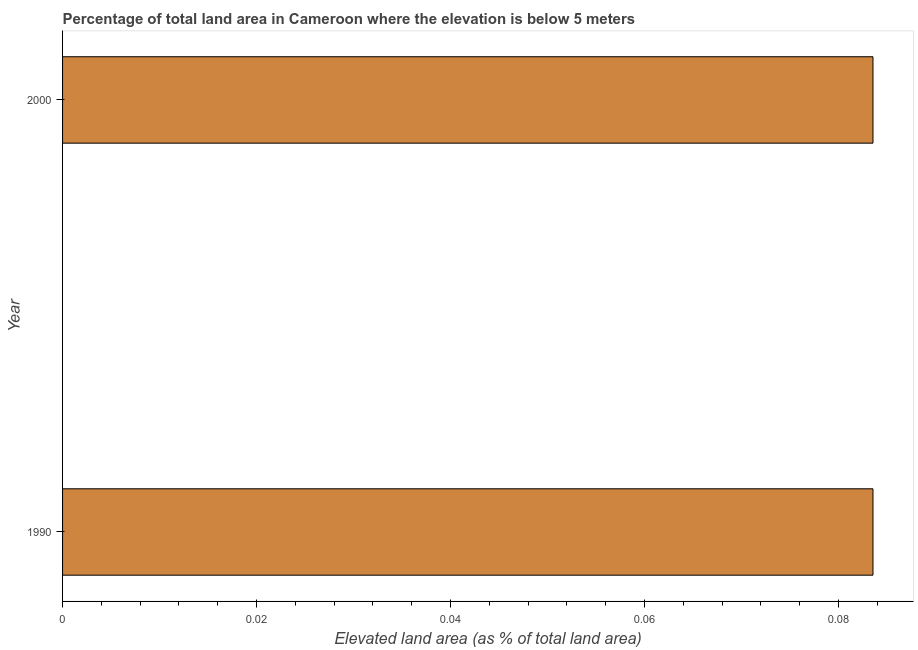Does the graph contain any zero values?
Your answer should be compact. No. Does the graph contain grids?
Your response must be concise. No. What is the title of the graph?
Provide a succinct answer. Percentage of total land area in Cameroon where the elevation is below 5 meters. What is the label or title of the X-axis?
Ensure brevity in your answer.  Elevated land area (as % of total land area). What is the label or title of the Y-axis?
Keep it short and to the point. Year. What is the total elevated land area in 1990?
Keep it short and to the point. 0.08. Across all years, what is the maximum total elevated land area?
Your answer should be compact. 0.08. Across all years, what is the minimum total elevated land area?
Keep it short and to the point. 0.08. In which year was the total elevated land area maximum?
Give a very brief answer. 1990. What is the sum of the total elevated land area?
Ensure brevity in your answer.  0.17. What is the difference between the total elevated land area in 1990 and 2000?
Your answer should be compact. 0. What is the average total elevated land area per year?
Provide a short and direct response. 0.08. What is the median total elevated land area?
Provide a succinct answer. 0.08. In how many years, is the total elevated land area greater than 0.056 %?
Your answer should be compact. 2. Do a majority of the years between 1990 and 2000 (inclusive) have total elevated land area greater than 0.06 %?
Make the answer very short. Yes. Is the total elevated land area in 1990 less than that in 2000?
Offer a very short reply. No. In how many years, is the total elevated land area greater than the average total elevated land area taken over all years?
Offer a terse response. 0. Are all the bars in the graph horizontal?
Offer a very short reply. Yes. How many years are there in the graph?
Offer a terse response. 2. What is the difference between two consecutive major ticks on the X-axis?
Offer a very short reply. 0.02. Are the values on the major ticks of X-axis written in scientific E-notation?
Provide a succinct answer. No. What is the Elevated land area (as % of total land area) of 1990?
Give a very brief answer. 0.08. What is the Elevated land area (as % of total land area) in 2000?
Provide a short and direct response. 0.08. What is the difference between the Elevated land area (as % of total land area) in 1990 and 2000?
Offer a terse response. 0. What is the ratio of the Elevated land area (as % of total land area) in 1990 to that in 2000?
Give a very brief answer. 1. 